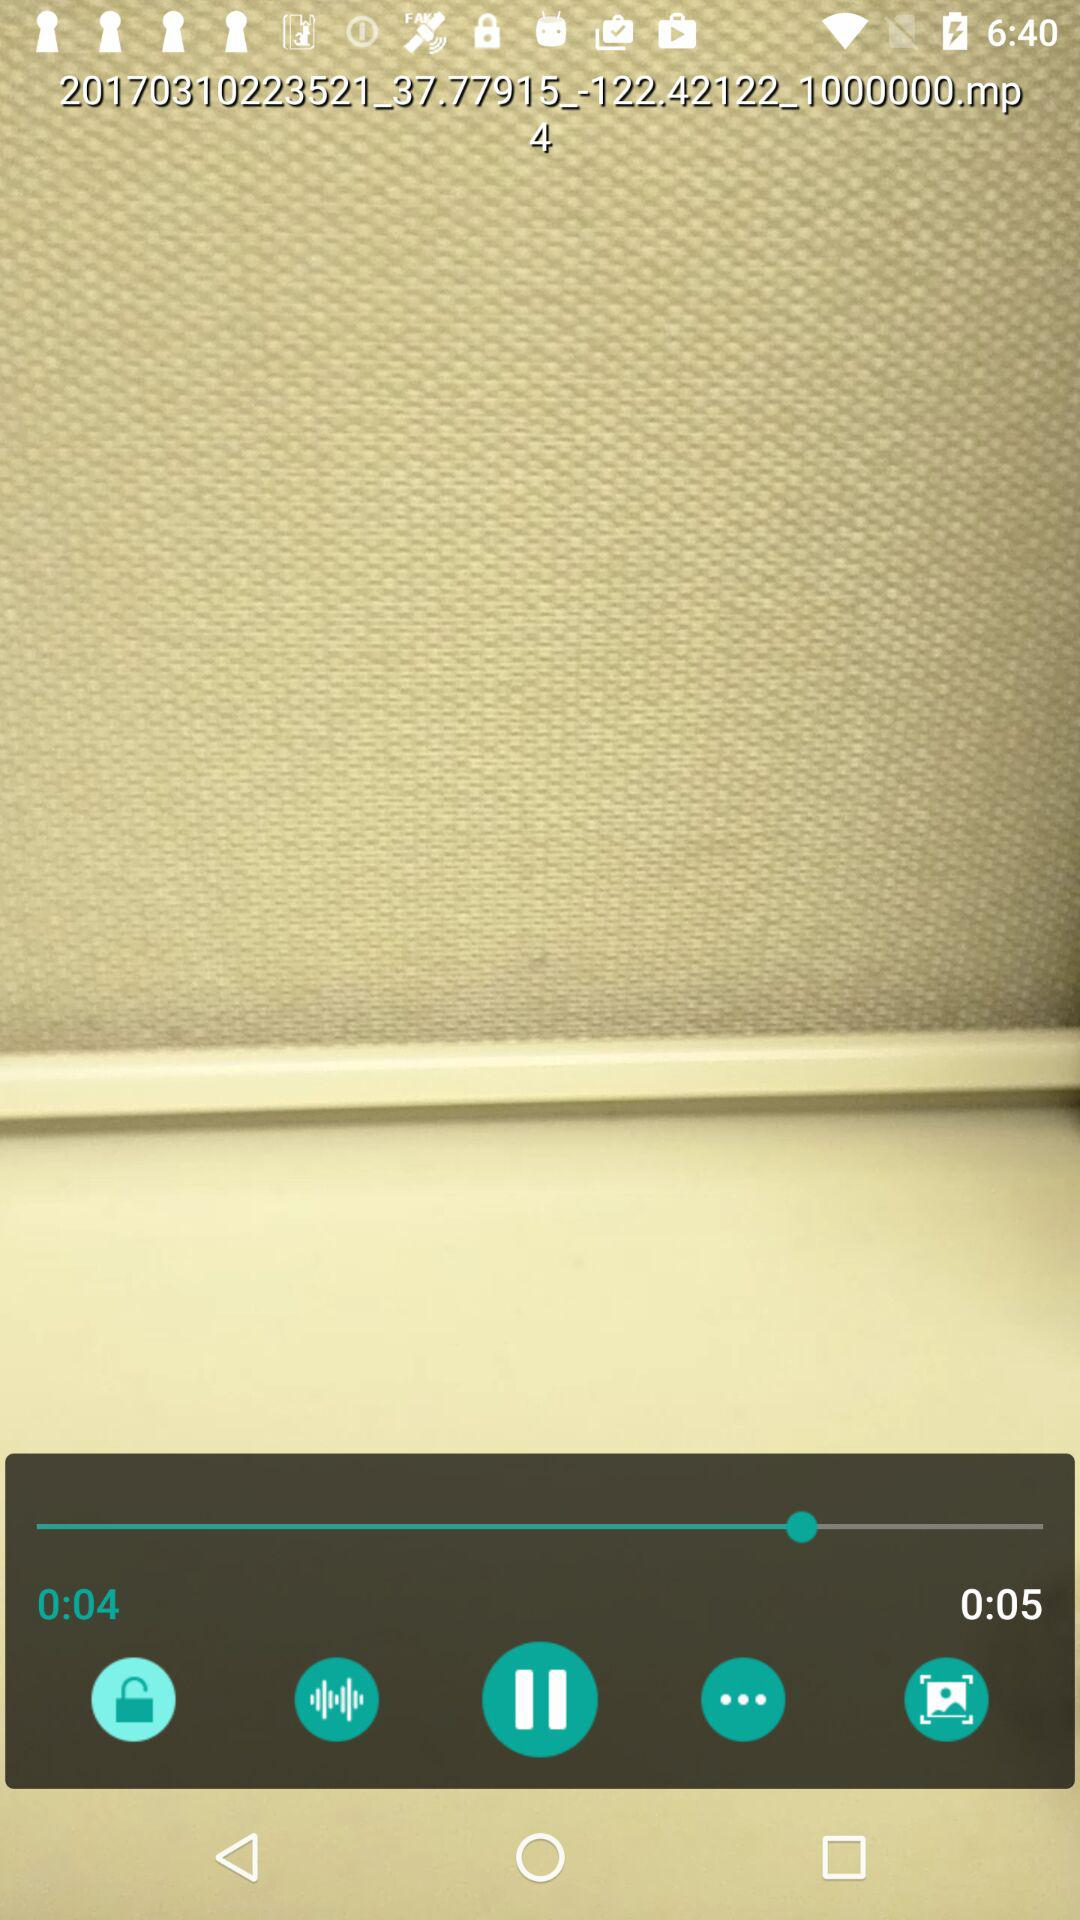What is the time duration of the audio? The time duration of the audio is 5 seconds. 